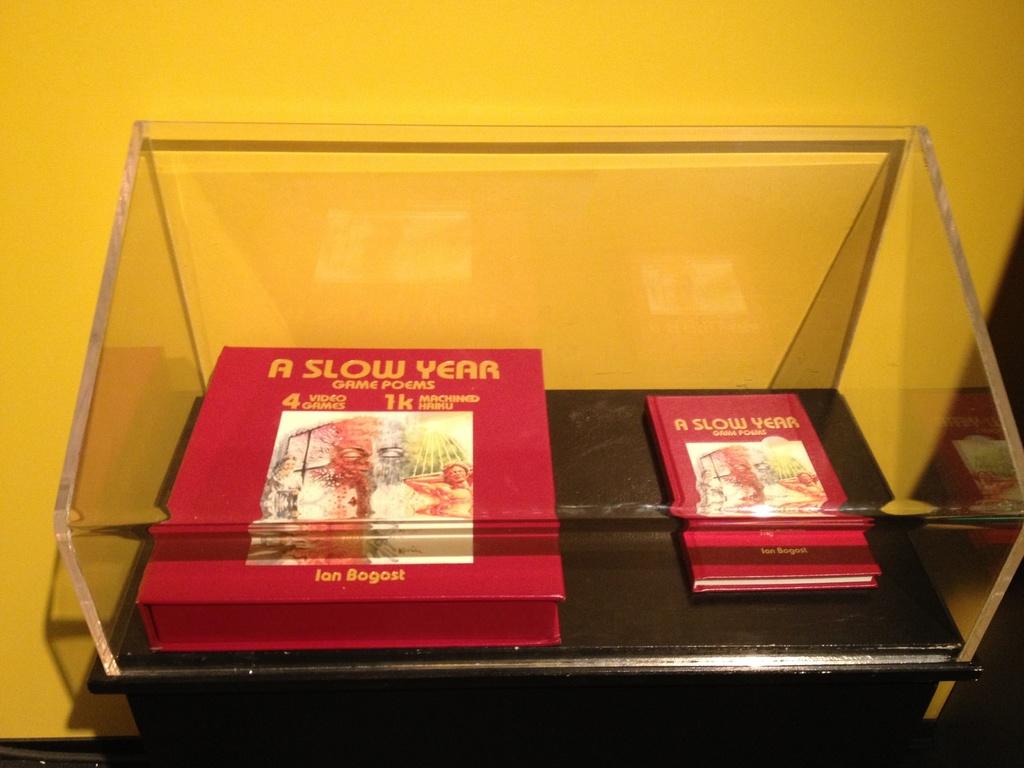Who wrote these poems?
Your response must be concise. Ian bogost. The title of the book is?
Provide a succinct answer. A slow year. 